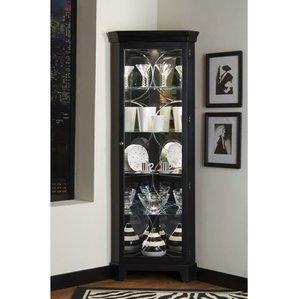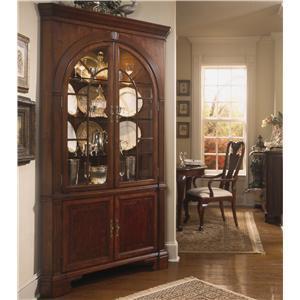The first image is the image on the left, the second image is the image on the right. For the images shown, is this caption "There are two drawers on the cabinet in the image on the left." true? Answer yes or no. No. 